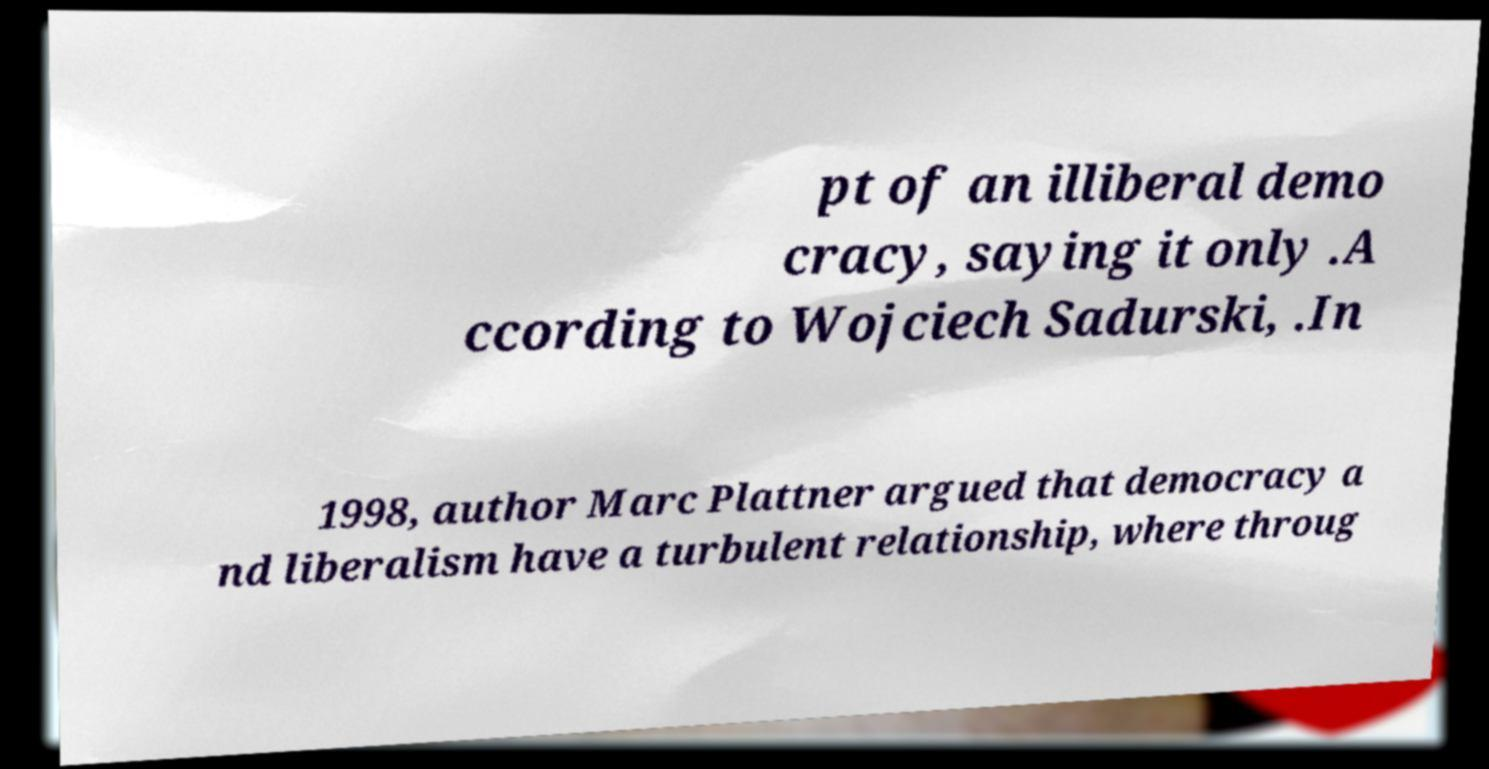Please identify and transcribe the text found in this image. pt of an illiberal demo cracy, saying it only .A ccording to Wojciech Sadurski, .In 1998, author Marc Plattner argued that democracy a nd liberalism have a turbulent relationship, where throug 